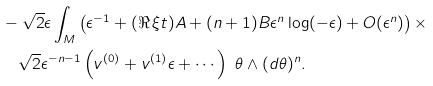Convert formula to latex. <formula><loc_0><loc_0><loc_500><loc_500>& - \sqrt { 2 } \epsilon \int _ { M } \left ( \epsilon ^ { - 1 } + ( \Re \, \xi t ) A + ( n + 1 ) B \epsilon ^ { n } \log ( - \epsilon ) + O ( \epsilon ^ { n } ) \right ) \times \\ & \quad \sqrt { 2 } \epsilon ^ { - n - 1 } \left ( v ^ { ( 0 ) } + v ^ { ( 1 ) } \epsilon + \cdots \right ) \ \theta \wedge ( d \theta ) ^ { n } .</formula> 